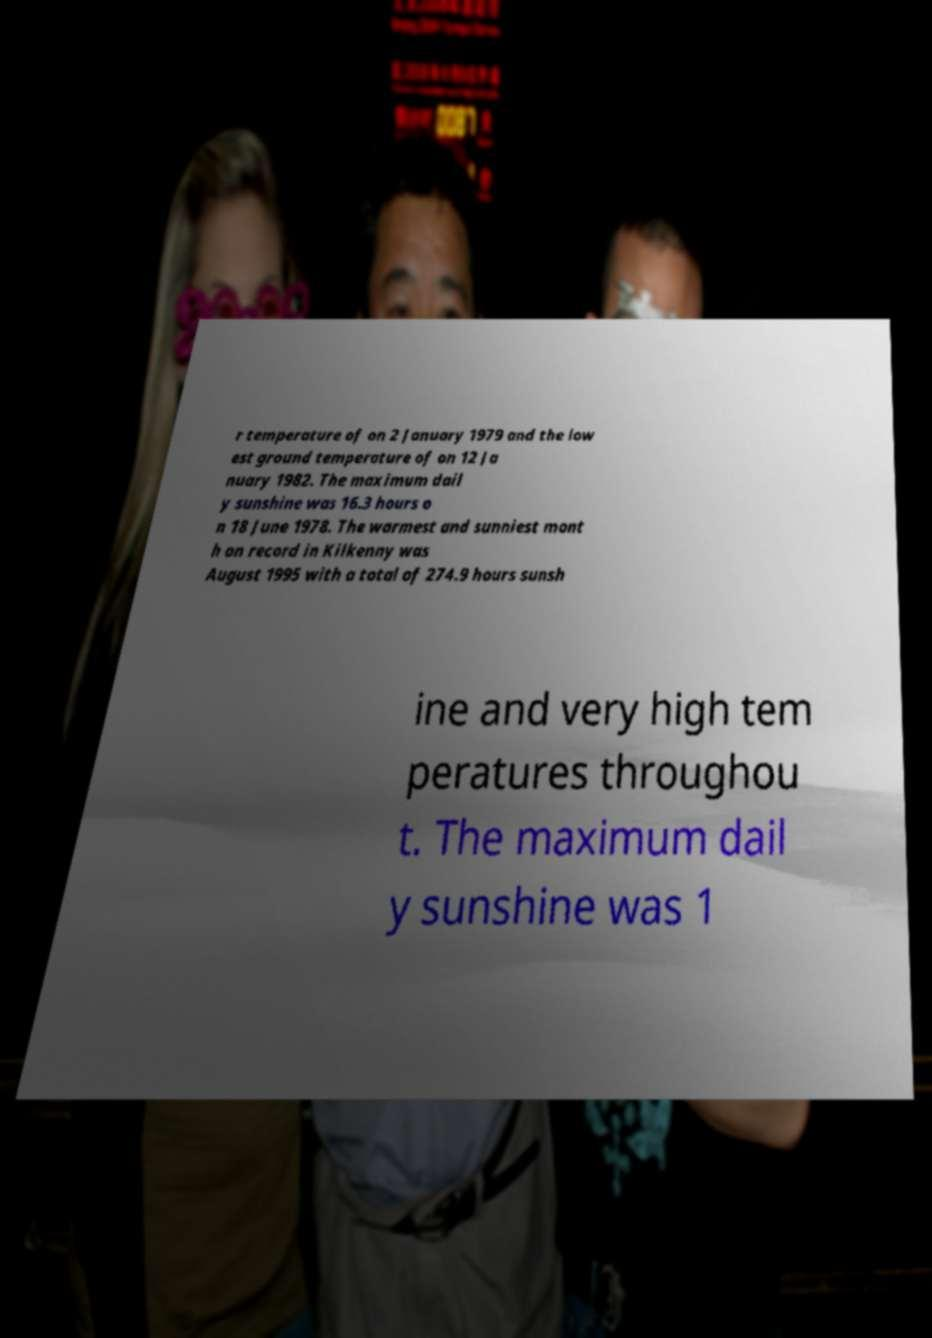For documentation purposes, I need the text within this image transcribed. Could you provide that? r temperature of on 2 January 1979 and the low est ground temperature of on 12 Ja nuary 1982. The maximum dail y sunshine was 16.3 hours o n 18 June 1978. The warmest and sunniest mont h on record in Kilkenny was August 1995 with a total of 274.9 hours sunsh ine and very high tem peratures throughou t. The maximum dail y sunshine was 1 